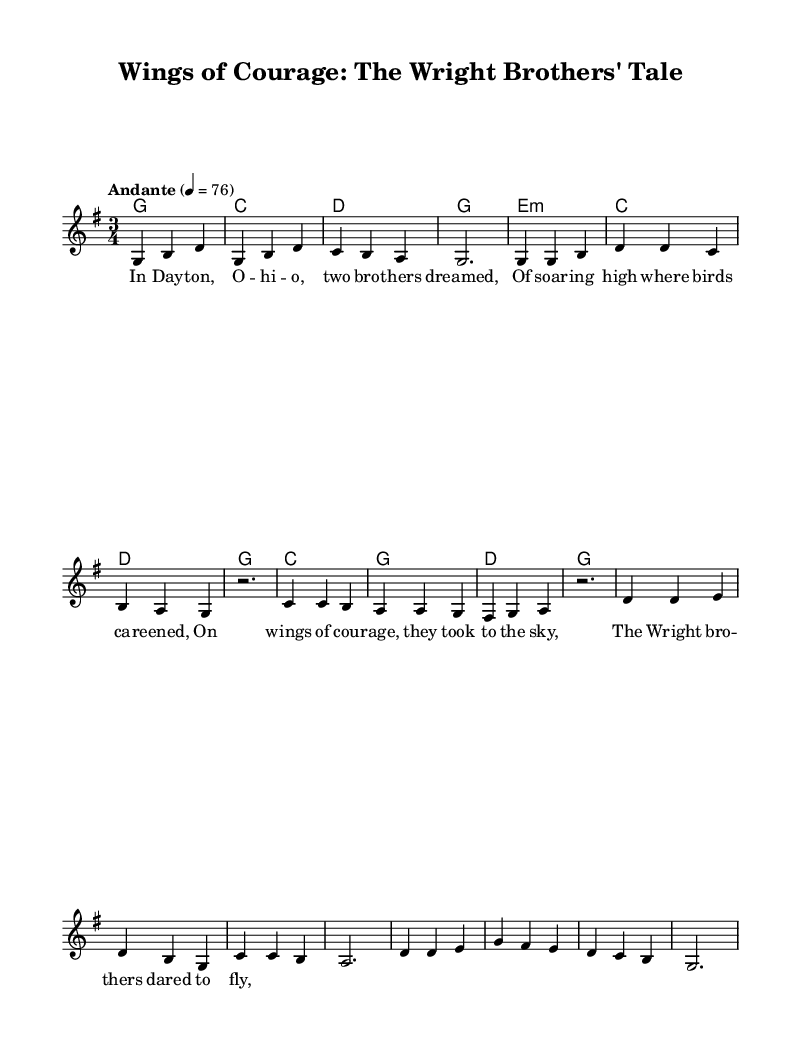What is the key signature of this music? The key signature is G major, which has one sharp (F#). This information is usually indicated at the beginning of the staff.
Answer: G major What is the time signature of this piece? The time signature is 3/4, which can be identified in the initial part of the sheet music. This signifies that there are three beats in each measure and the quarter note gets one beat.
Answer: 3/4 What is the tempo marking for this music? The tempo marking is "Andante," which indicates a moderate walking pace. It is shown at the start of the music.
Answer: Andante How many measures are in the melody section? There are ten measures in the melody section. This can be counted by reviewing each segment of the melody notation provided.
Answer: 10 What type of folk theme does this ballad represent? The theme represents aviation pioneers, specifically highlighting the Wright Brothers and their dream of flight. The lyrics narrated in the verses clearly depict this historical subject matter.
Answer: Aviation pioneers What is the structure of the song in terms of sections? The structure consists of an introduction, followed by verses and a chorus. This can be deduced by the distinct divisions and the lyrical components provided in the score.
Answer: Intro, Verse, Chorus What is the introductory motif of the melody? The introductory motif consists of ascending and descending notes beginning with G, indicating a hopeful and uplifting tone to match the theme of courage in aviation. The first few notes of the melody clearly depict this figure.
Answer: Ascending and descending notes 